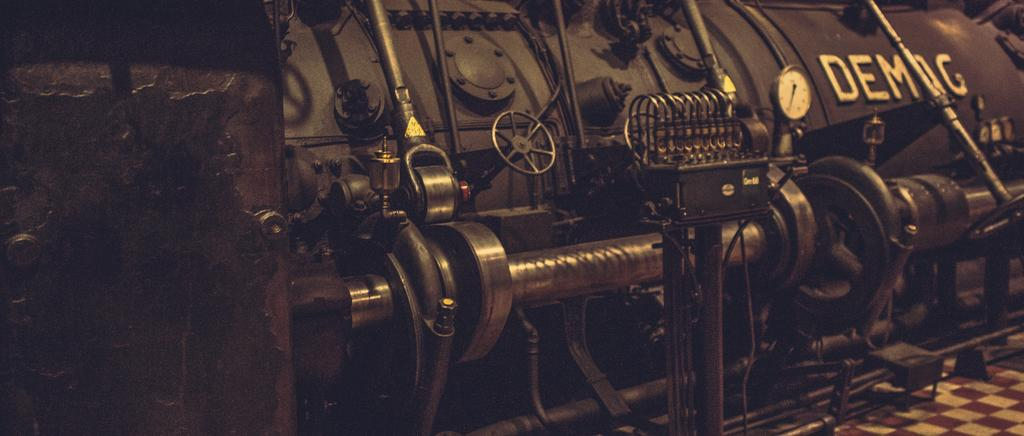What type of location is depicted in the image? The image appears to be taken in a factory. What can be seen in the factory? There is a metal machine in the image. What part of the factory is visible in the image? The floor is visible in the image. What type of haircut does the machine have in the image? The machine in the image does not have a haircut, as it is a metal machine and not a living being. 